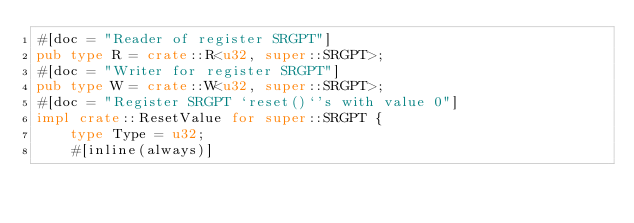Convert code to text. <code><loc_0><loc_0><loc_500><loc_500><_Rust_>#[doc = "Reader of register SRGPT"]
pub type R = crate::R<u32, super::SRGPT>;
#[doc = "Writer for register SRGPT"]
pub type W = crate::W<u32, super::SRGPT>;
#[doc = "Register SRGPT `reset()`'s with value 0"]
impl crate::ResetValue for super::SRGPT {
    type Type = u32;
    #[inline(always)]</code> 